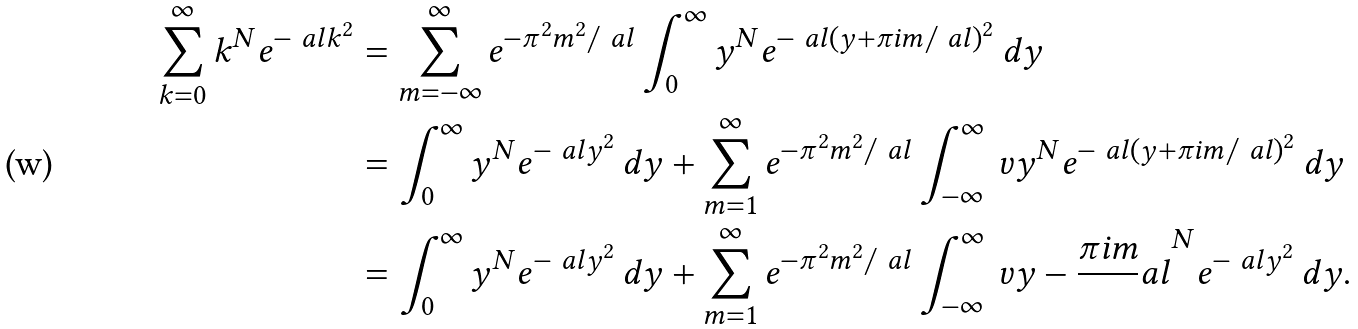<formula> <loc_0><loc_0><loc_500><loc_500>\sum _ { k = 0 } ^ { \infty } k ^ { N } e ^ { - \ a l k ^ { 2 } } & = \sum _ { m = - \infty } ^ { \infty } e ^ { - \pi ^ { 2 } m ^ { 2 } / \ a l } \int _ { 0 } ^ { \infty } y ^ { N } e ^ { - \ a l ( y + \pi i m / \ a l ) ^ { 2 } } \, d y \\ & = \int _ { 0 } ^ { \infty } y ^ { N } e ^ { - \ a l y ^ { 2 } } \, d y + \sum _ { m = 1 } ^ { \infty } e ^ { - \pi ^ { 2 } m ^ { 2 } / \ a l } \int _ { - \infty } ^ { \infty } { \ v y } ^ { N } e ^ { - \ a l ( y + \pi i m / \ a l ) ^ { 2 } } \, d y \\ & = \int _ { 0 } ^ { \infty } y ^ { N } e ^ { - \ a l y ^ { 2 } } \, d y + \sum _ { m = 1 } ^ { \infty } e ^ { - \pi ^ { 2 } m ^ { 2 } / \ a l } \int _ { - \infty } ^ { \infty } \ v { y - \frac { \pi i m } \ a l } ^ { N } e ^ { - \ a l y ^ { 2 } } \, d y .</formula> 